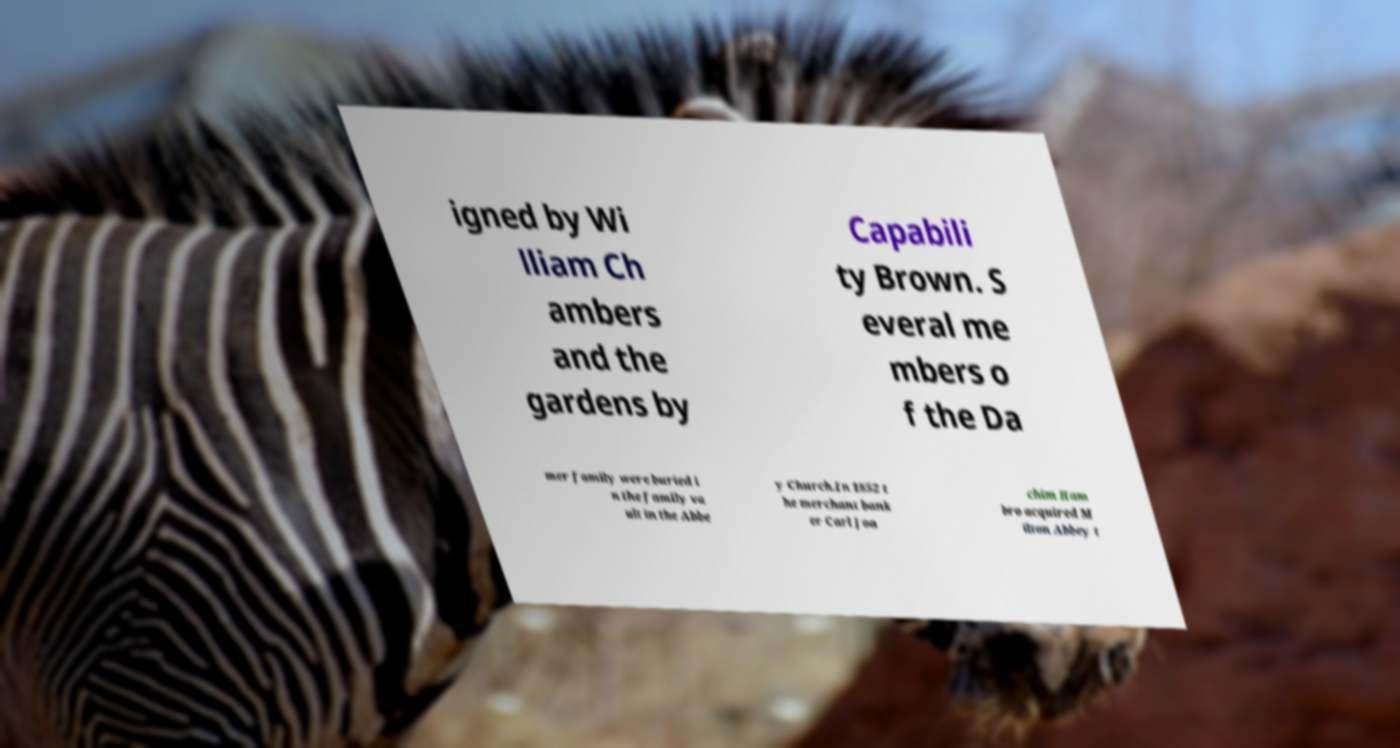Can you read and provide the text displayed in the image?This photo seems to have some interesting text. Can you extract and type it out for me? igned by Wi lliam Ch ambers and the gardens by Capabili ty Brown. S everal me mbers o f the Da mer family were buried i n the family va ult in the Abbe y Church.In 1852 t he merchant bank er Carl Joa chim Ham bro acquired M ilton Abbey t 